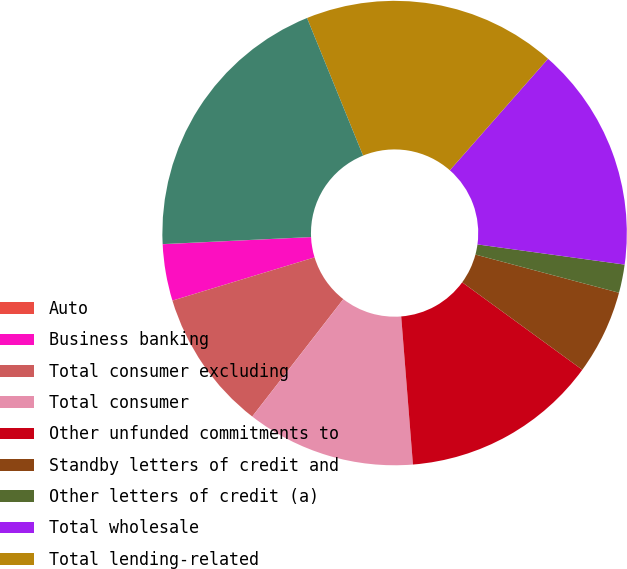Convert chart. <chart><loc_0><loc_0><loc_500><loc_500><pie_chart><fcel>Auto<fcel>Business banking<fcel>Total consumer excluding<fcel>Total consumer<fcel>Other unfunded commitments to<fcel>Standby letters of credit and<fcel>Other letters of credit (a)<fcel>Total wholesale<fcel>Total lending-related<fcel>Derivatives qualifying as<nl><fcel>0.01%<fcel>3.93%<fcel>9.8%<fcel>11.76%<fcel>13.72%<fcel>5.88%<fcel>1.97%<fcel>15.68%<fcel>17.64%<fcel>19.6%<nl></chart> 